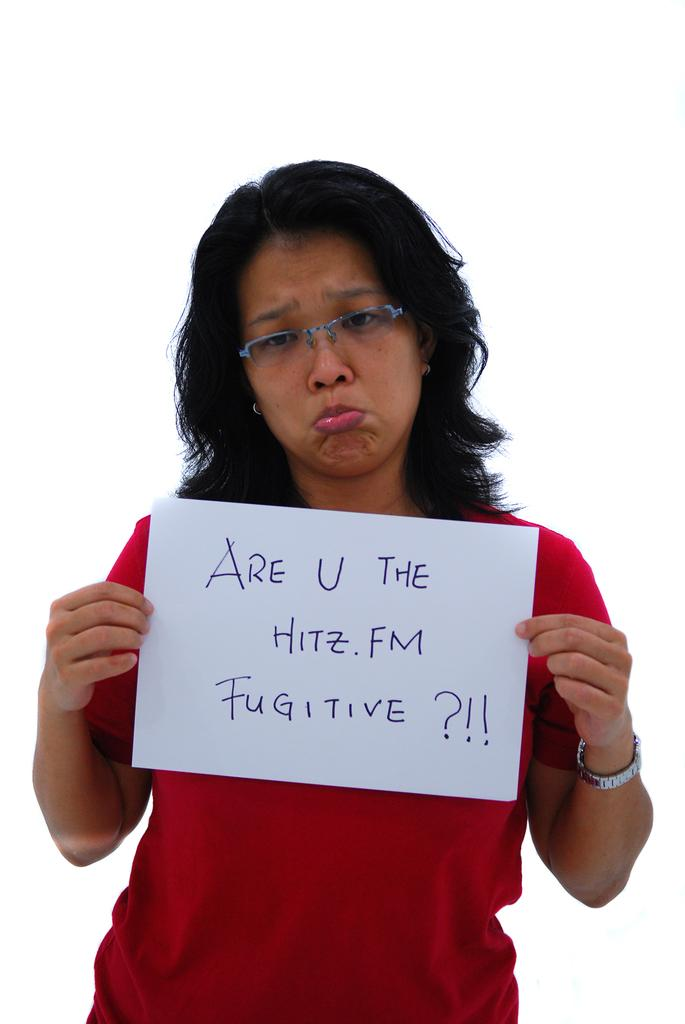<image>
Write a terse but informative summary of the picture. A girl in a red shirt is holding a hand written sign that says Are U The Hitz FM Fugitive. 